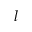Convert formula to latex. <formula><loc_0><loc_0><loc_500><loc_500>l</formula> 